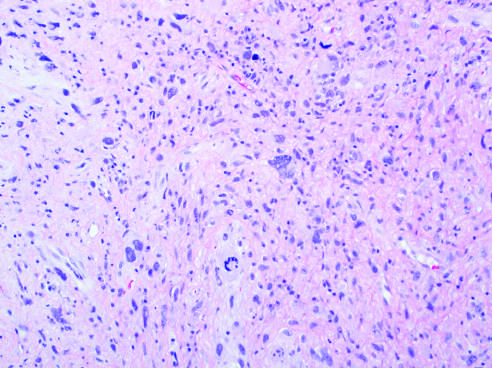s carcinoma in situ spindled to polygonal cells?
Answer the question using a single word or phrase. No 